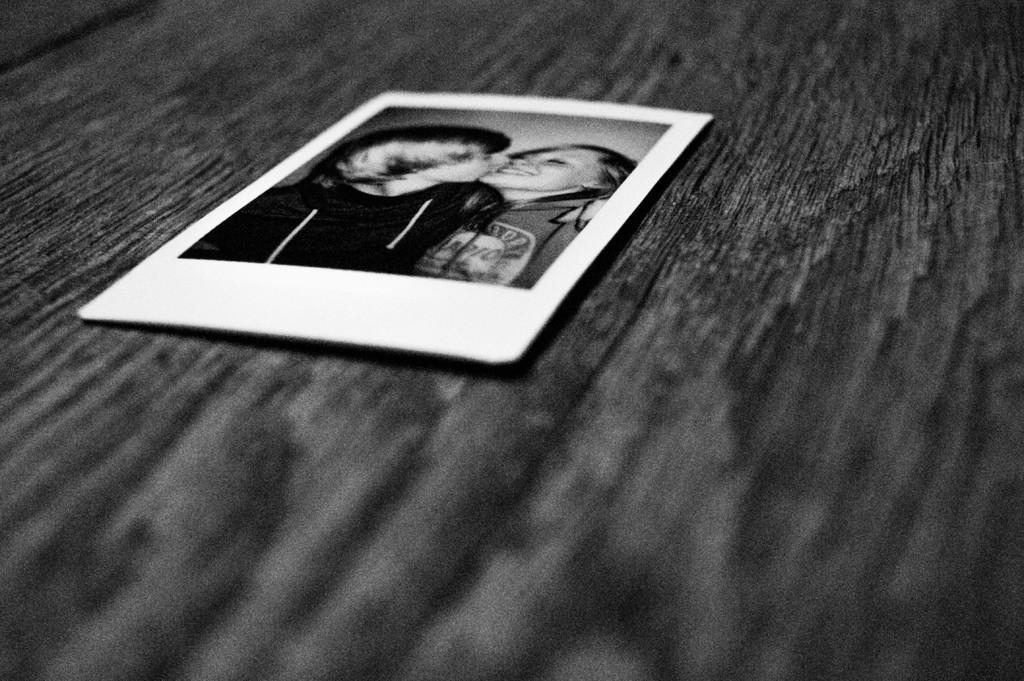What is the color scheme of the image? The image is black and white. What can be seen on the table in the image? There is a photo placed on a table in the image. How many houses are visible in the image? There are no houses visible in the image, as it only features a photo placed on a table. What is the level of noise in the image? The level of noise cannot be determined from the image, as it is a still photograph and does not convey sound. 